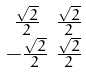Convert formula to latex. <formula><loc_0><loc_0><loc_500><loc_500>\begin{smallmatrix} \frac { \sqrt { 2 } } { 2 } & \frac { \sqrt { 2 } } { 2 } \\ - \frac { \sqrt { 2 } } { 2 } & \frac { \sqrt { 2 } } { 2 } \\ \end{smallmatrix}</formula> 